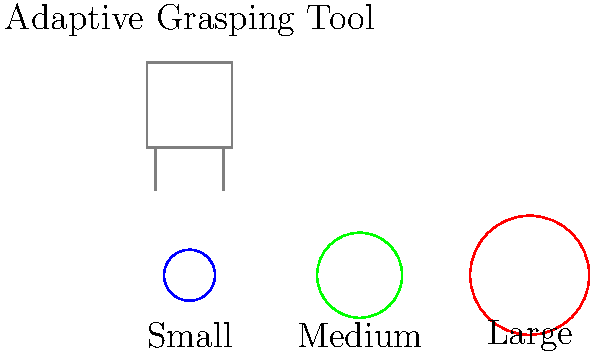Using the adaptive grasping tool shown in the image, how would you sort the three objects by size? Describe the order in which you would pick up the objects, from smallest to largest. To sort the objects by size using the adaptive grasping tool, follow these steps:

1. Observe the objects: There are three circular objects of different sizes - small (blue), medium (green), and large (red).

2. Understand the adaptive grasping tool: The tool has adjustable grips that can accommodate different object sizes.

3. Start with the smallest object:
   a. Adjust the grips of the tool to match the size of the small blue object.
   b. Pick up the small blue object first.

4. Move to the medium-sized object:
   a. Widen the grips of the tool slightly to match the size of the medium green object.
   b. Pick up the medium green object second.

5. Finally, pick up the largest object:
   a. Widen the grips of the tool further to accommodate the large red object.
   b. Pick up the large red object last.

6. The correct order of picking up the objects from smallest to largest is:
   Blue (small) → Green (medium) → Red (large)

This sorting method allows for a gradual increase in grip size, making it easier to manage the objects with the adaptive grasping tool.
Answer: Blue, Green, Red 